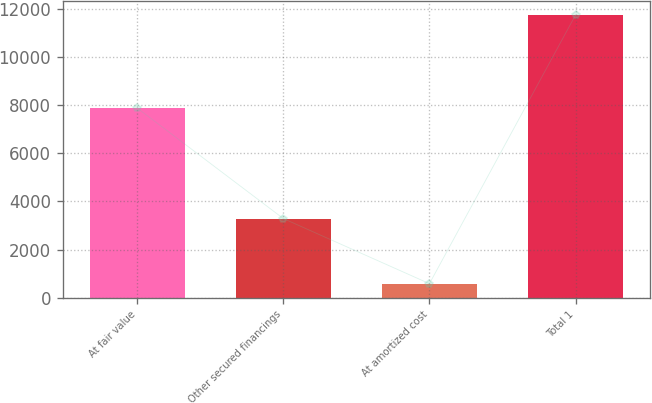Convert chart. <chart><loc_0><loc_0><loc_500><loc_500><bar_chart><fcel>At fair value<fcel>Other secured financings<fcel>At amortized cost<fcel>Total 1<nl><fcel>7887<fcel>3290<fcel>580<fcel>11762<nl></chart> 